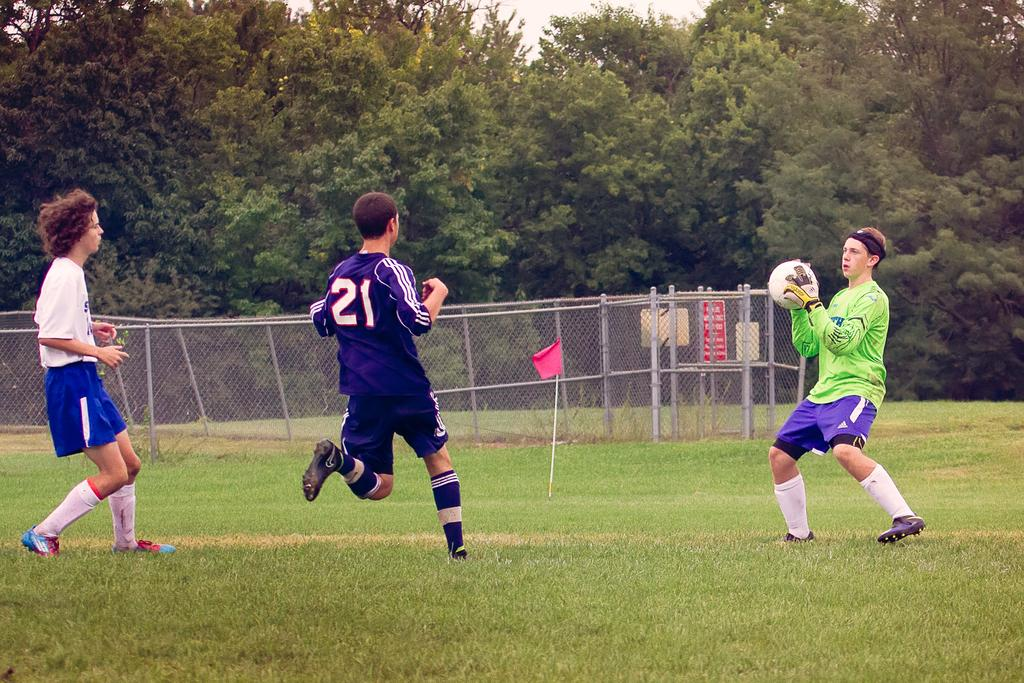How many people are present in the image? There are three people standing in the image. What is one person holding in the image? One person is holding a white color ball. What can be seen in the image besides the people? There is a pink flag, fencing, signboards, and trees in the image. Can you see any fish swimming in the image? There are no fish visible in the image. What type of land can be seen in the background of the image? The image does not show any land in the background; it only features trees. 